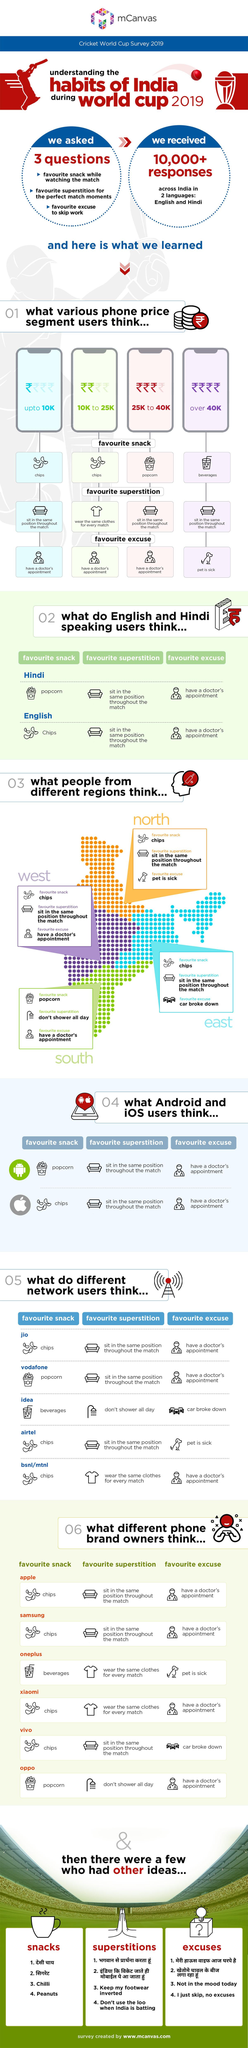Mention a couple of crucial points in this snapshot. All network users, including Jio, Airtel, and BSNL/MTNL, enjoy chips as their favorite snack. According to the responses provided, at least two phone brand owners have the same superstition of wearing the same clothes for every match. The number of identical answers among Android and iOS users is two. Of the answers given by Hindi-speaking users and English-speaking users, how many are the same? The answer is two. According to a survey, the favorite snack of phone users with a budget of 25k to 40k is popcorn. 